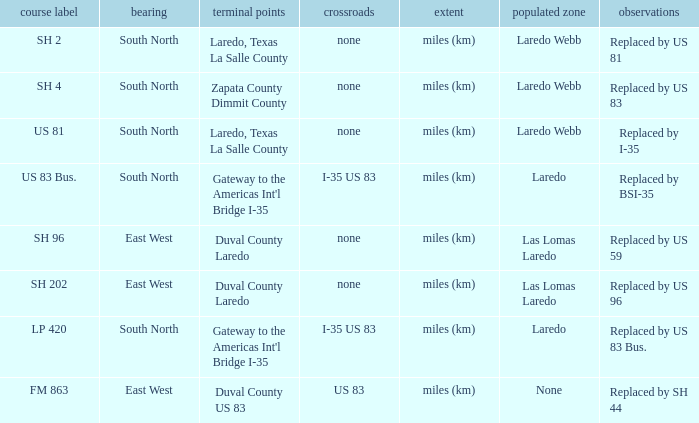Which junctions have "replaced by bsi-35" listed in their remarks section? I-35 US 83. 